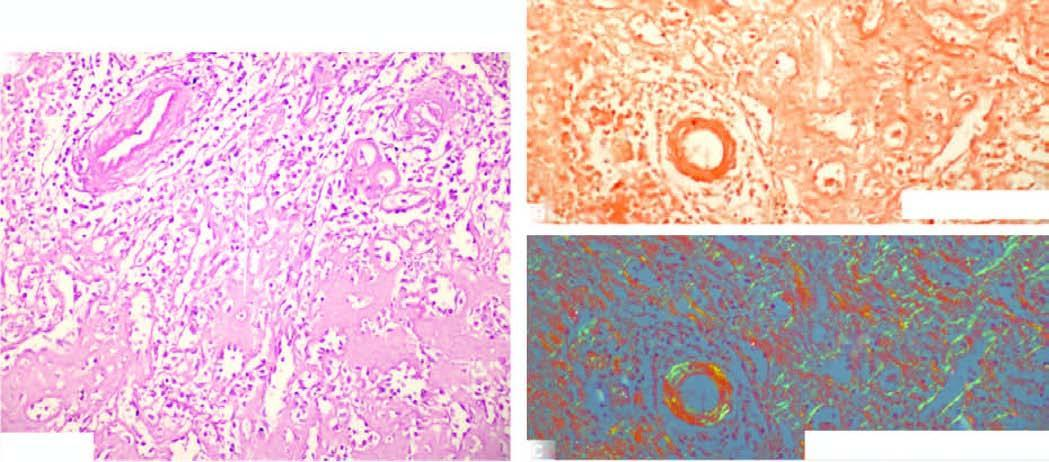do the deposits show apple-green birefringence?
Answer the question using a single word or phrase. No 